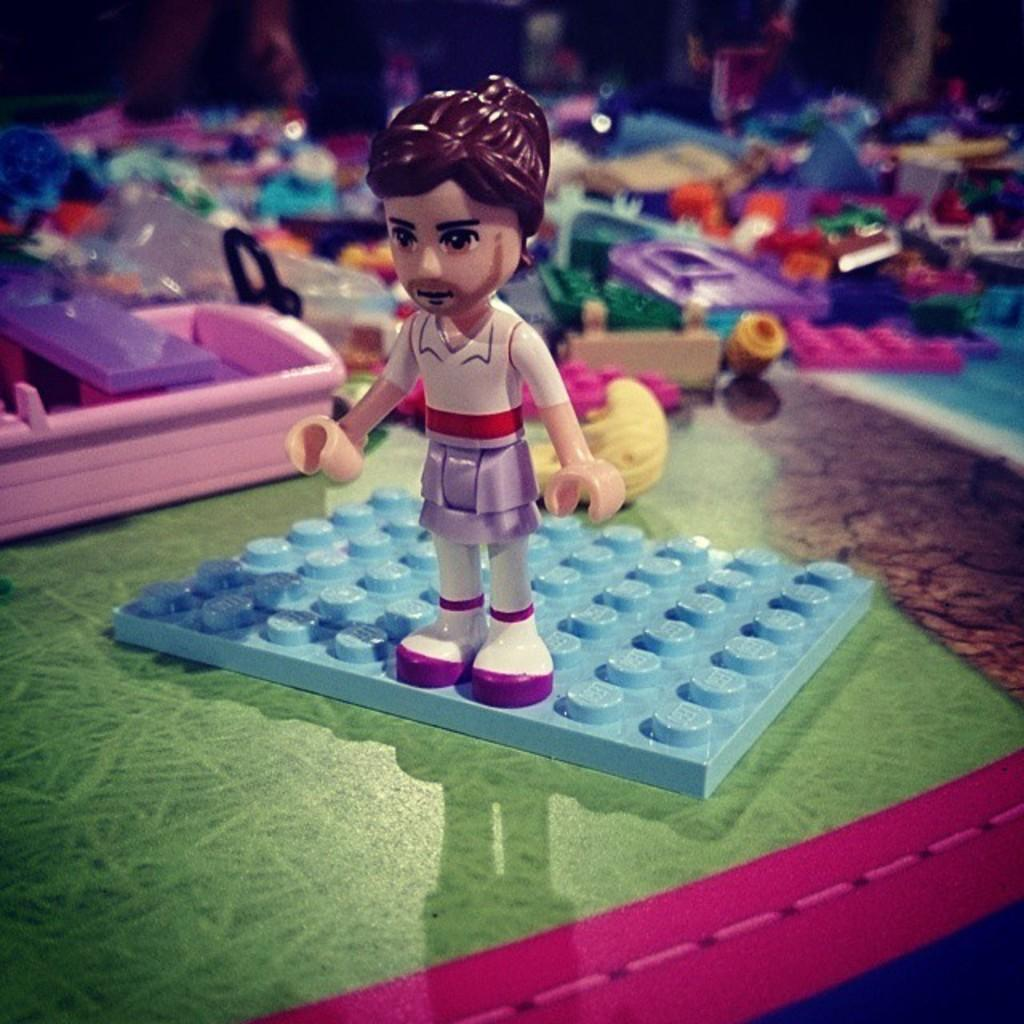What objects are present on the mat in the image? There are toys on a mat in the image. Can you describe the background of the image? The background of the image is blurry. What type of cactus can be seen in the image? There is no cactus present in the image; it only features toys on a mat and a blurry background. 